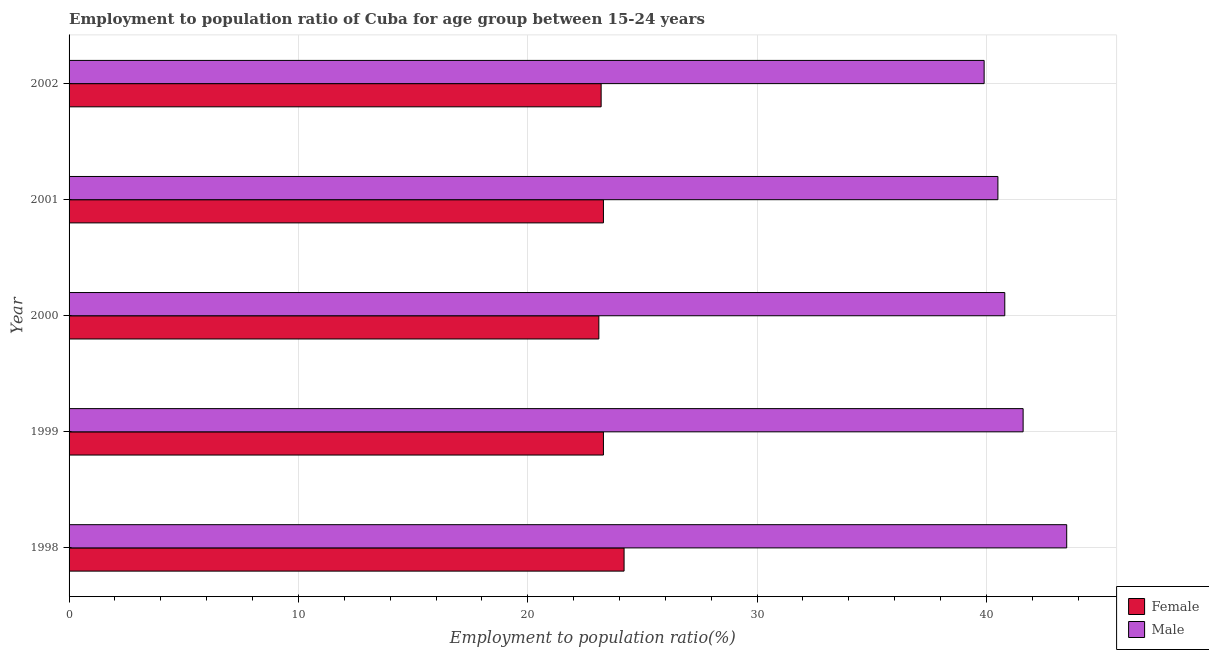Are the number of bars per tick equal to the number of legend labels?
Provide a succinct answer. Yes. Are the number of bars on each tick of the Y-axis equal?
Your answer should be compact. Yes. How many bars are there on the 1st tick from the top?
Provide a short and direct response. 2. How many bars are there on the 4th tick from the bottom?
Your response must be concise. 2. What is the employment to population ratio(female) in 2002?
Keep it short and to the point. 23.2. Across all years, what is the maximum employment to population ratio(female)?
Your answer should be very brief. 24.2. Across all years, what is the minimum employment to population ratio(male)?
Provide a succinct answer. 39.9. What is the total employment to population ratio(male) in the graph?
Your answer should be very brief. 206.3. What is the difference between the employment to population ratio(male) in 1999 and that in 2000?
Give a very brief answer. 0.8. What is the difference between the employment to population ratio(female) in 2002 and the employment to population ratio(male) in 1998?
Ensure brevity in your answer.  -20.3. What is the average employment to population ratio(female) per year?
Ensure brevity in your answer.  23.42. In the year 1998, what is the difference between the employment to population ratio(female) and employment to population ratio(male)?
Your answer should be compact. -19.3. In how many years, is the employment to population ratio(female) greater than 30 %?
Your answer should be compact. 0. What is the ratio of the employment to population ratio(female) in 1998 to that in 2000?
Offer a very short reply. 1.05. What is the difference between the highest and the second highest employment to population ratio(male)?
Offer a terse response. 1.9. In how many years, is the employment to population ratio(female) greater than the average employment to population ratio(female) taken over all years?
Ensure brevity in your answer.  1. What does the 2nd bar from the bottom in 1998 represents?
Keep it short and to the point. Male. Does the graph contain any zero values?
Keep it short and to the point. No. Where does the legend appear in the graph?
Offer a terse response. Bottom right. How many legend labels are there?
Provide a succinct answer. 2. What is the title of the graph?
Offer a terse response. Employment to population ratio of Cuba for age group between 15-24 years. Does "Old" appear as one of the legend labels in the graph?
Your answer should be compact. No. What is the label or title of the X-axis?
Keep it short and to the point. Employment to population ratio(%). What is the Employment to population ratio(%) of Female in 1998?
Offer a terse response. 24.2. What is the Employment to population ratio(%) of Male in 1998?
Provide a short and direct response. 43.5. What is the Employment to population ratio(%) of Female in 1999?
Keep it short and to the point. 23.3. What is the Employment to population ratio(%) in Male in 1999?
Your response must be concise. 41.6. What is the Employment to population ratio(%) in Female in 2000?
Provide a succinct answer. 23.1. What is the Employment to population ratio(%) of Male in 2000?
Provide a succinct answer. 40.8. What is the Employment to population ratio(%) in Female in 2001?
Keep it short and to the point. 23.3. What is the Employment to population ratio(%) in Male in 2001?
Provide a short and direct response. 40.5. What is the Employment to population ratio(%) in Female in 2002?
Provide a succinct answer. 23.2. What is the Employment to population ratio(%) in Male in 2002?
Offer a very short reply. 39.9. Across all years, what is the maximum Employment to population ratio(%) of Female?
Your answer should be compact. 24.2. Across all years, what is the maximum Employment to population ratio(%) in Male?
Provide a succinct answer. 43.5. Across all years, what is the minimum Employment to population ratio(%) of Female?
Make the answer very short. 23.1. Across all years, what is the minimum Employment to population ratio(%) of Male?
Your response must be concise. 39.9. What is the total Employment to population ratio(%) of Female in the graph?
Your response must be concise. 117.1. What is the total Employment to population ratio(%) of Male in the graph?
Make the answer very short. 206.3. What is the difference between the Employment to population ratio(%) of Male in 1998 and that in 2000?
Give a very brief answer. 2.7. What is the difference between the Employment to population ratio(%) of Female in 1998 and that in 2001?
Make the answer very short. 0.9. What is the difference between the Employment to population ratio(%) of Female in 1999 and that in 2000?
Offer a very short reply. 0.2. What is the difference between the Employment to population ratio(%) in Male in 1999 and that in 2000?
Your answer should be compact. 0.8. What is the difference between the Employment to population ratio(%) in Female in 1999 and that in 2001?
Offer a very short reply. 0. What is the difference between the Employment to population ratio(%) in Male in 1999 and that in 2001?
Your answer should be very brief. 1.1. What is the difference between the Employment to population ratio(%) of Female in 1999 and that in 2002?
Keep it short and to the point. 0.1. What is the difference between the Employment to population ratio(%) in Male in 2000 and that in 2001?
Provide a succinct answer. 0.3. What is the difference between the Employment to population ratio(%) of Female in 2000 and that in 2002?
Keep it short and to the point. -0.1. What is the difference between the Employment to population ratio(%) in Male in 2000 and that in 2002?
Ensure brevity in your answer.  0.9. What is the difference between the Employment to population ratio(%) of Female in 1998 and the Employment to population ratio(%) of Male in 1999?
Make the answer very short. -17.4. What is the difference between the Employment to population ratio(%) of Female in 1998 and the Employment to population ratio(%) of Male in 2000?
Your answer should be compact. -16.6. What is the difference between the Employment to population ratio(%) in Female in 1998 and the Employment to population ratio(%) in Male in 2001?
Your answer should be compact. -16.3. What is the difference between the Employment to population ratio(%) of Female in 1998 and the Employment to population ratio(%) of Male in 2002?
Give a very brief answer. -15.7. What is the difference between the Employment to population ratio(%) in Female in 1999 and the Employment to population ratio(%) in Male in 2000?
Your answer should be very brief. -17.5. What is the difference between the Employment to population ratio(%) of Female in 1999 and the Employment to population ratio(%) of Male in 2001?
Offer a very short reply. -17.2. What is the difference between the Employment to population ratio(%) in Female in 1999 and the Employment to population ratio(%) in Male in 2002?
Your answer should be very brief. -16.6. What is the difference between the Employment to population ratio(%) of Female in 2000 and the Employment to population ratio(%) of Male in 2001?
Offer a terse response. -17.4. What is the difference between the Employment to population ratio(%) of Female in 2000 and the Employment to population ratio(%) of Male in 2002?
Offer a very short reply. -16.8. What is the difference between the Employment to population ratio(%) of Female in 2001 and the Employment to population ratio(%) of Male in 2002?
Provide a short and direct response. -16.6. What is the average Employment to population ratio(%) of Female per year?
Keep it short and to the point. 23.42. What is the average Employment to population ratio(%) in Male per year?
Provide a short and direct response. 41.26. In the year 1998, what is the difference between the Employment to population ratio(%) of Female and Employment to population ratio(%) of Male?
Provide a succinct answer. -19.3. In the year 1999, what is the difference between the Employment to population ratio(%) of Female and Employment to population ratio(%) of Male?
Make the answer very short. -18.3. In the year 2000, what is the difference between the Employment to population ratio(%) of Female and Employment to population ratio(%) of Male?
Provide a succinct answer. -17.7. In the year 2001, what is the difference between the Employment to population ratio(%) in Female and Employment to population ratio(%) in Male?
Your response must be concise. -17.2. In the year 2002, what is the difference between the Employment to population ratio(%) of Female and Employment to population ratio(%) of Male?
Make the answer very short. -16.7. What is the ratio of the Employment to population ratio(%) in Female in 1998 to that in 1999?
Keep it short and to the point. 1.04. What is the ratio of the Employment to population ratio(%) of Male in 1998 to that in 1999?
Your response must be concise. 1.05. What is the ratio of the Employment to population ratio(%) in Female in 1998 to that in 2000?
Keep it short and to the point. 1.05. What is the ratio of the Employment to population ratio(%) in Male in 1998 to that in 2000?
Your answer should be very brief. 1.07. What is the ratio of the Employment to population ratio(%) in Female in 1998 to that in 2001?
Ensure brevity in your answer.  1.04. What is the ratio of the Employment to population ratio(%) in Male in 1998 to that in 2001?
Keep it short and to the point. 1.07. What is the ratio of the Employment to population ratio(%) of Female in 1998 to that in 2002?
Your answer should be compact. 1.04. What is the ratio of the Employment to population ratio(%) of Male in 1998 to that in 2002?
Your answer should be very brief. 1.09. What is the ratio of the Employment to population ratio(%) in Female in 1999 to that in 2000?
Your answer should be very brief. 1.01. What is the ratio of the Employment to population ratio(%) in Male in 1999 to that in 2000?
Provide a short and direct response. 1.02. What is the ratio of the Employment to population ratio(%) of Male in 1999 to that in 2001?
Your answer should be compact. 1.03. What is the ratio of the Employment to population ratio(%) of Female in 1999 to that in 2002?
Ensure brevity in your answer.  1. What is the ratio of the Employment to population ratio(%) in Male in 1999 to that in 2002?
Ensure brevity in your answer.  1.04. What is the ratio of the Employment to population ratio(%) of Female in 2000 to that in 2001?
Keep it short and to the point. 0.99. What is the ratio of the Employment to population ratio(%) of Male in 2000 to that in 2001?
Make the answer very short. 1.01. What is the ratio of the Employment to population ratio(%) of Female in 2000 to that in 2002?
Keep it short and to the point. 1. What is the ratio of the Employment to population ratio(%) in Male in 2000 to that in 2002?
Offer a very short reply. 1.02. What is the ratio of the Employment to population ratio(%) of Female in 2001 to that in 2002?
Your response must be concise. 1. What is the ratio of the Employment to population ratio(%) in Male in 2001 to that in 2002?
Provide a short and direct response. 1.01. What is the difference between the highest and the second highest Employment to population ratio(%) of Male?
Your answer should be compact. 1.9. What is the difference between the highest and the lowest Employment to population ratio(%) of Male?
Make the answer very short. 3.6. 